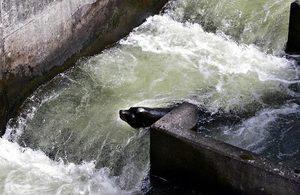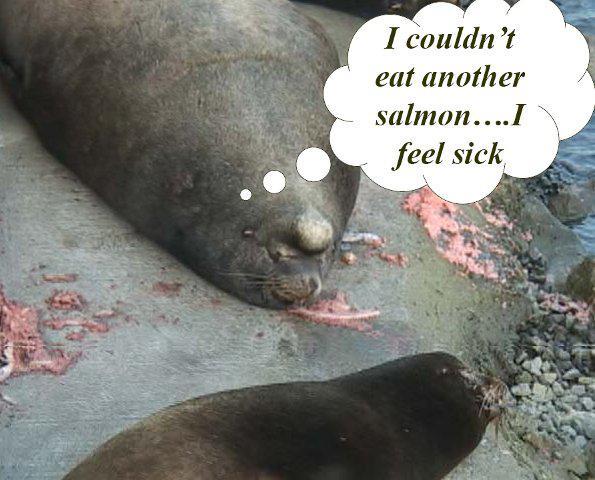The first image is the image on the left, the second image is the image on the right. Assess this claim about the two images: "Each image shows one dark seal with its head showing above water, and in at least one image, the seal is chewing on torn orange-fleshed fish.". Correct or not? Answer yes or no. No. 